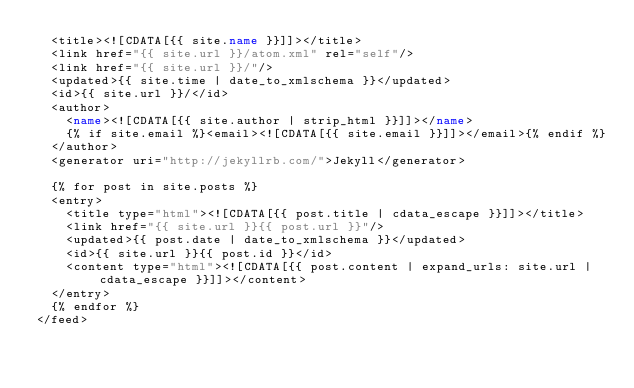Convert code to text. <code><loc_0><loc_0><loc_500><loc_500><_XML_>  <title><![CDATA[{{ site.name }}]]></title>
  <link href="{{ site.url }}/atom.xml" rel="self"/>
  <link href="{{ site.url }}/"/>
  <updated>{{ site.time | date_to_xmlschema }}</updated>
  <id>{{ site.url }}/</id>
  <author>
    <name><![CDATA[{{ site.author | strip_html }}]]></name>
    {% if site.email %}<email><![CDATA[{{ site.email }}]]></email>{% endif %}
  </author>
  <generator uri="http://jekyllrb.com/">Jekyll</generator>

  {% for post in site.posts %}
  <entry>
    <title type="html"><![CDATA[{{ post.title | cdata_escape }}]]></title>
    <link href="{{ site.url }}{{ post.url }}"/>
    <updated>{{ post.date | date_to_xmlschema }}</updated>
    <id>{{ site.url }}{{ post.id }}</id>
    <content type="html"><![CDATA[{{ post.content | expand_urls: site.url | cdata_escape }}]]></content>
  </entry>
  {% endfor %}
</feed>
</code> 